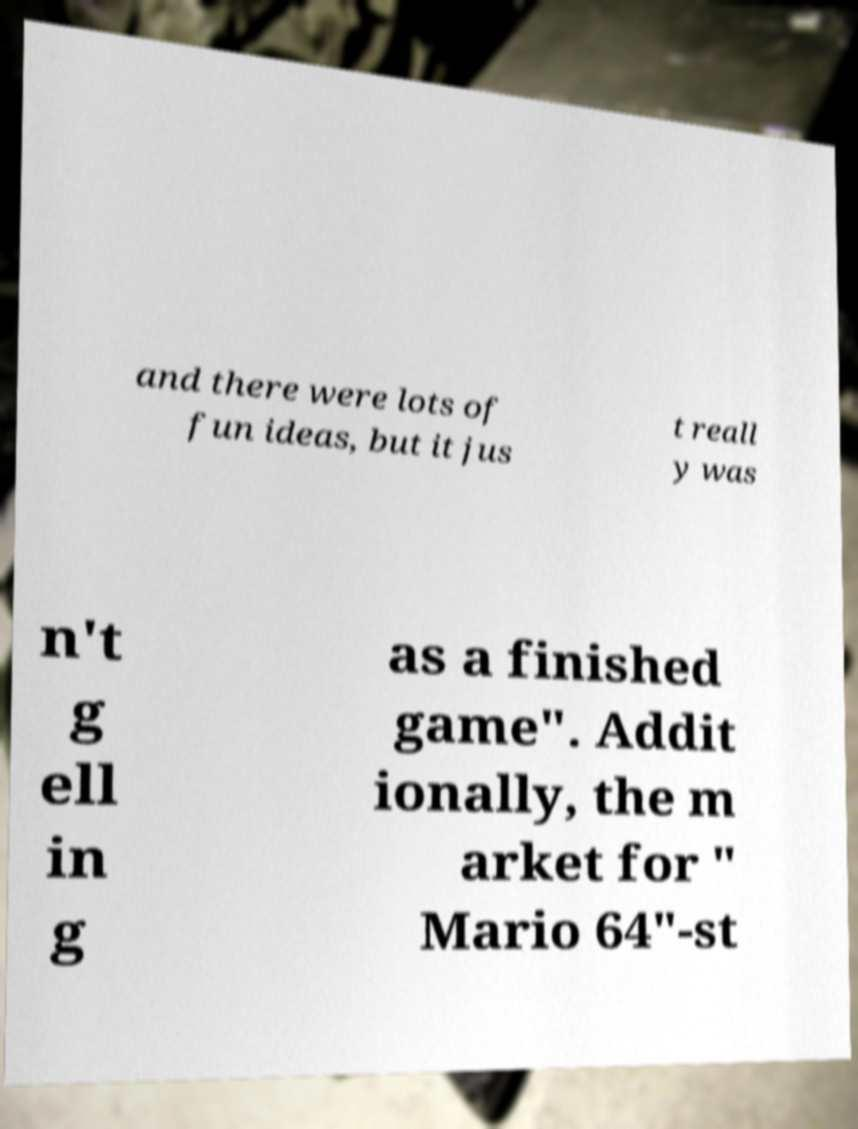Please read and relay the text visible in this image. What does it say? and there were lots of fun ideas, but it jus t reall y was n't g ell in g as a finished game". Addit ionally, the m arket for " Mario 64"-st 